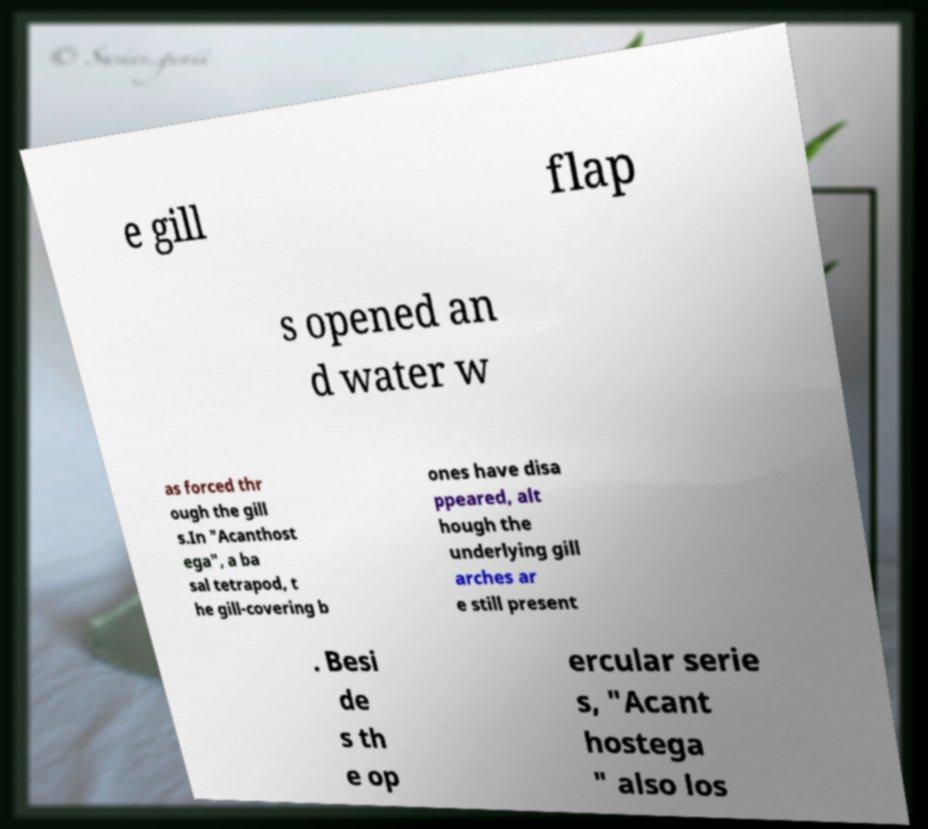For documentation purposes, I need the text within this image transcribed. Could you provide that? e gill flap s opened an d water w as forced thr ough the gill s.In "Acanthost ega", a ba sal tetrapod, t he gill-covering b ones have disa ppeared, alt hough the underlying gill arches ar e still present . Besi de s th e op ercular serie s, "Acant hostega " also los 